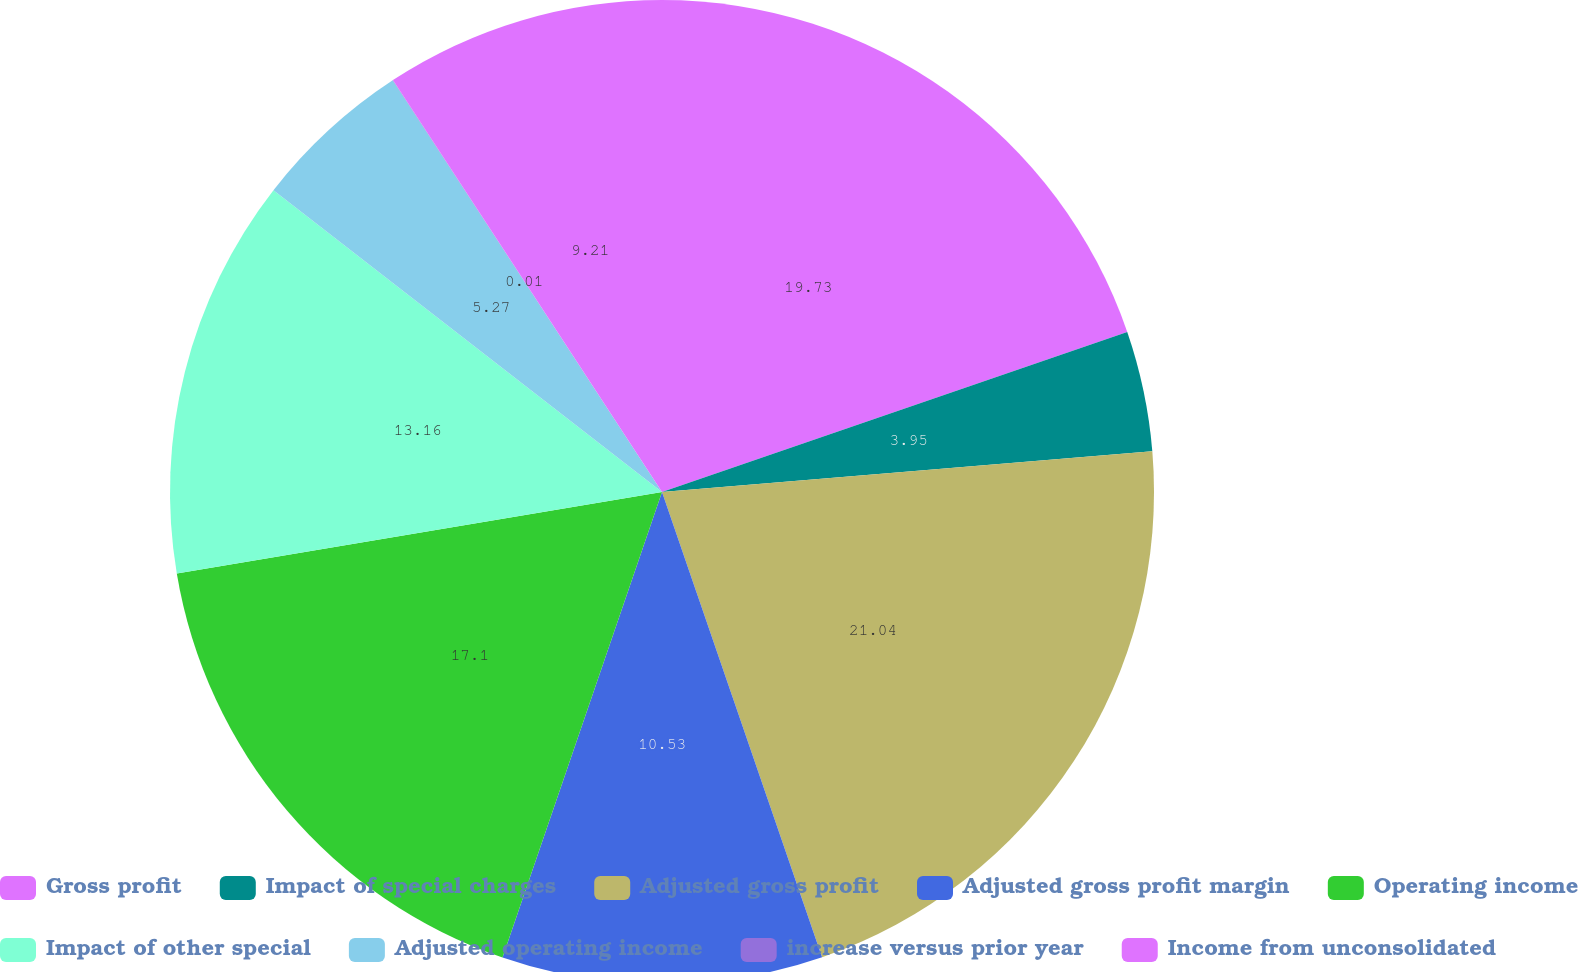Convert chart to OTSL. <chart><loc_0><loc_0><loc_500><loc_500><pie_chart><fcel>Gross profit<fcel>Impact of special charges<fcel>Adjusted gross profit<fcel>Adjusted gross profit margin<fcel>Operating income<fcel>Impact of other special<fcel>Adjusted operating income<fcel>increase versus prior year<fcel>Income from unconsolidated<nl><fcel>19.73%<fcel>3.95%<fcel>21.05%<fcel>10.53%<fcel>17.1%<fcel>13.16%<fcel>5.27%<fcel>0.01%<fcel>9.21%<nl></chart> 